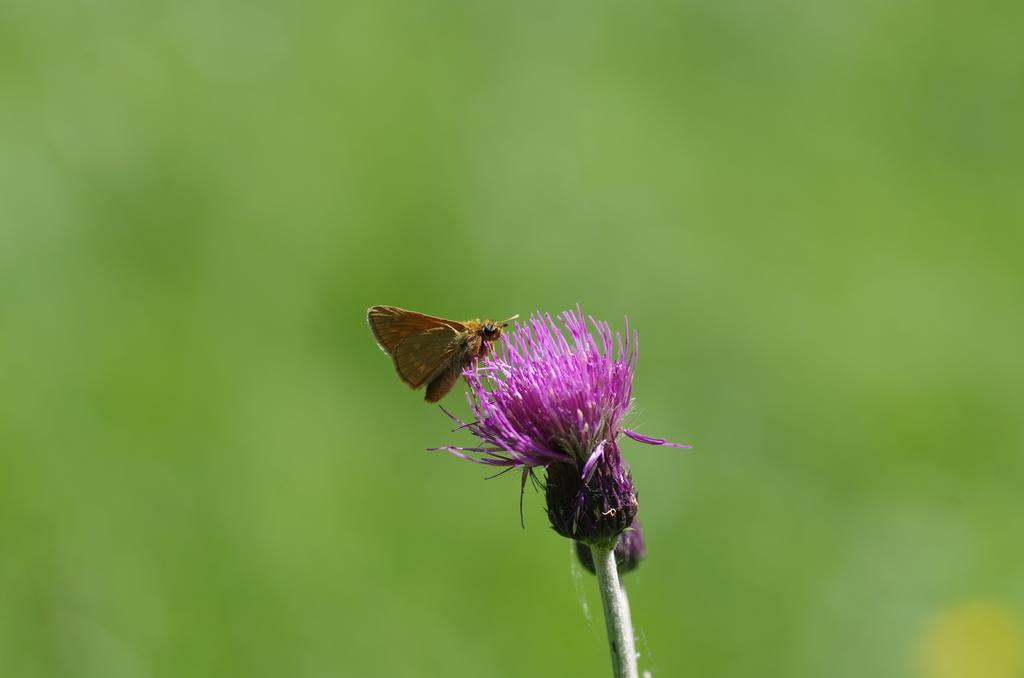Can you describe this image briefly? In this image we can see an insect on a pink colored flower and the background is blurred and green in color. 